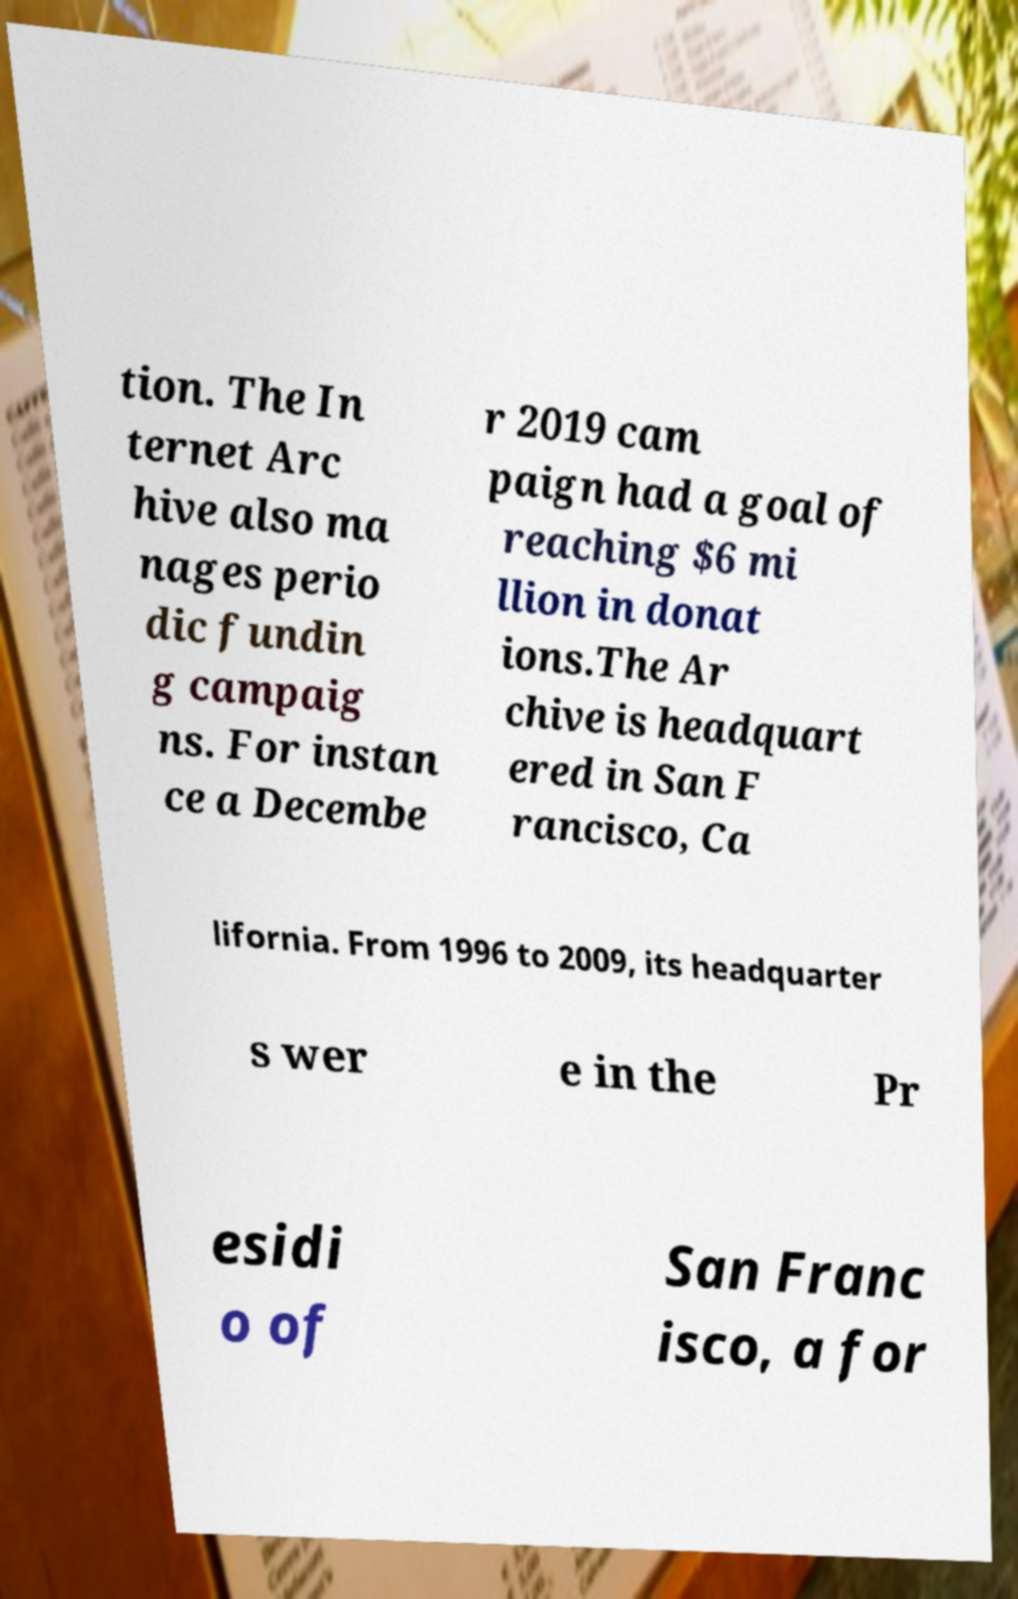Can you read and provide the text displayed in the image?This photo seems to have some interesting text. Can you extract and type it out for me? tion. The In ternet Arc hive also ma nages perio dic fundin g campaig ns. For instan ce a Decembe r 2019 cam paign had a goal of reaching $6 mi llion in donat ions.The Ar chive is headquart ered in San F rancisco, Ca lifornia. From 1996 to 2009, its headquarter s wer e in the Pr esidi o of San Franc isco, a for 